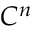Convert formula to latex. <formula><loc_0><loc_0><loc_500><loc_500>C ^ { n }</formula> 